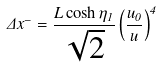Convert formula to latex. <formula><loc_0><loc_0><loc_500><loc_500>\Delta x ^ { - } = \frac { L \cosh \eta _ { 1 } } { \sqrt { 2 } } \left ( \frac { u _ { 0 } } { u } \right ) ^ { 4 }</formula> 